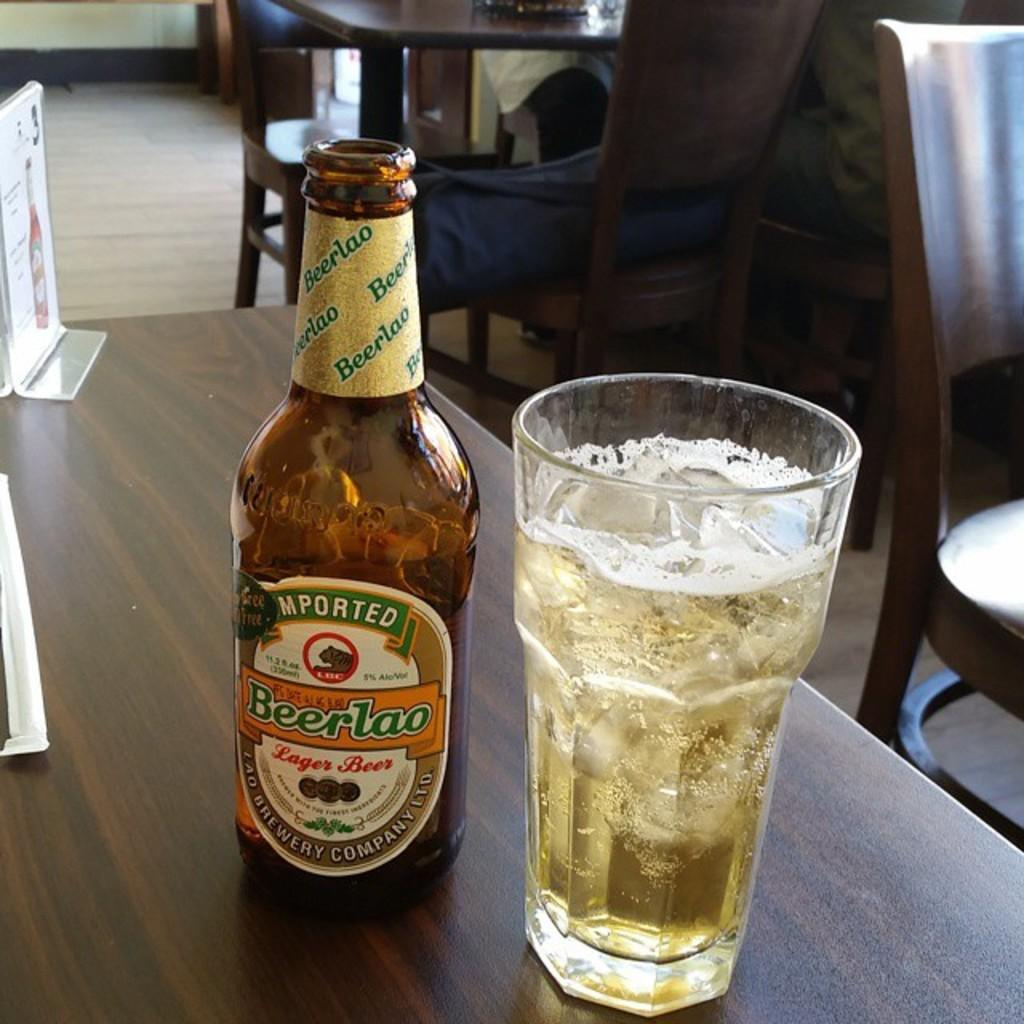What is present on the table in the image? There is a bottle and a glass on the table in the image. What else can be seen in the image besides the table and its contents? There is a board and chairs beside the table in the image. What is the purpose of the board in the image? The purpose of the board in the image is not specified, but it could be used for writing, displaying information, or as a decorative element. Is there a flame visible on the board in the image? No, there is no flame visible on the board or anywhere else in the image. How much sugar is present in the glass in the image? There is no mention of sugar or any other contents in the glass, so we cannot determine the amount of sugar present. 